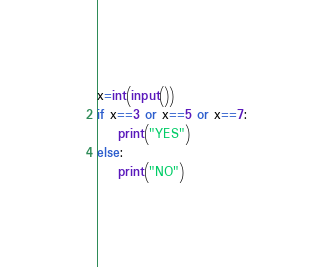Convert code to text. <code><loc_0><loc_0><loc_500><loc_500><_Python_>x=int(input())
if x==3 or x==5 or x==7:
    print("YES")
else:
    print("NO")</code> 